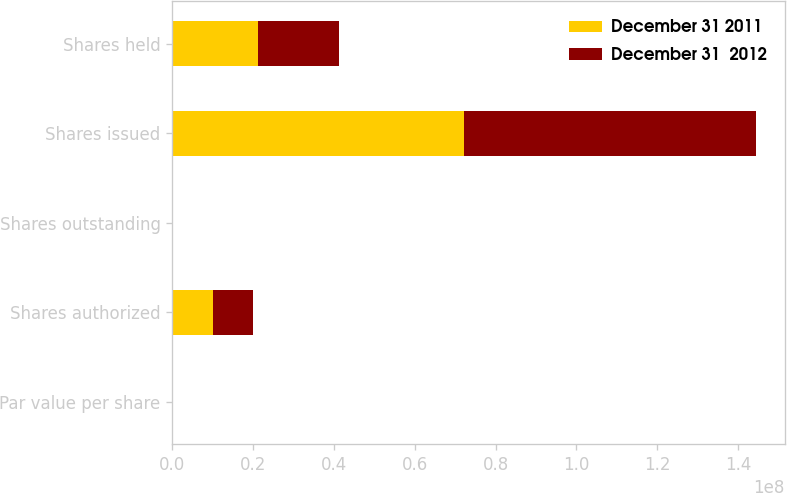Convert chart. <chart><loc_0><loc_0><loc_500><loc_500><stacked_bar_chart><ecel><fcel>Par value per share<fcel>Shares authorized<fcel>Shares outstanding<fcel>Shares issued<fcel>Shares held<nl><fcel>December 31 2011<fcel>0.01<fcel>1e+07<fcel>0<fcel>7.21519e+07<fcel>2.12436e+07<nl><fcel>December 31  2012<fcel>0.01<fcel>1e+07<fcel>0<fcel>7.21519e+07<fcel>2.00567e+07<nl></chart> 